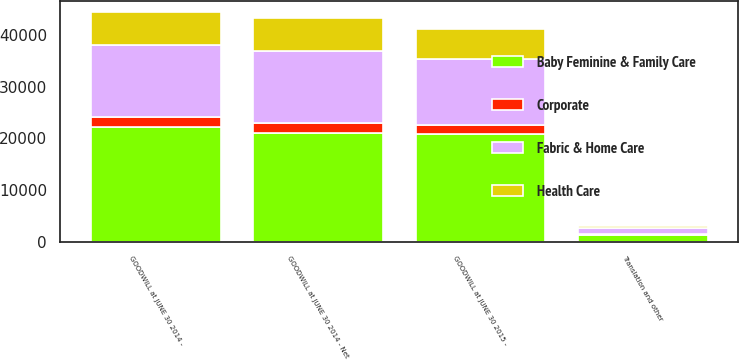Convert chart. <chart><loc_0><loc_0><loc_500><loc_500><stacked_bar_chart><ecel><fcel>GOODWILL at JUNE 30 2014 -<fcel>GOODWILL at JUNE 30 2014 - Net<fcel>Translation and other<fcel>GOODWILL at JUNE 30 2015 -<nl><fcel>Fabric & Home Care<fcel>14065<fcel>14065<fcel>1225<fcel>12704<nl><fcel>Baby Feminine & Family Care<fcel>22097<fcel>20939<fcel>1320<fcel>20777<nl><fcel>Health Care<fcel>6280<fcel>6280<fcel>398<fcel>5876<nl><fcel>Corporate<fcel>1981<fcel>1981<fcel>104<fcel>1874<nl></chart> 